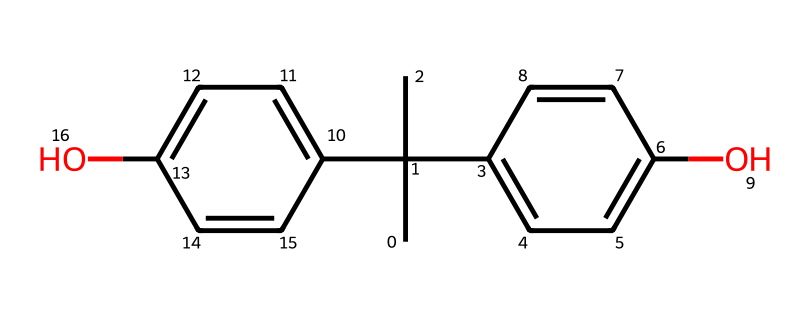What is the molecular formula of bisphenol A? To determine the molecular formula from the SMILES, we can parse it to identify the number and types of atoms present. In this case, the structure contains 15 carbon atoms, 16 hydrogen atoms, and 2 oxygen atoms. Thus, the molecular formula is C15H16O2.
Answer: C15H16O2 How many hydroxyl groups are present in bisphenol A? By examining the structure, we can identify the hydroxyl groups (-OH) which are represented by the oxygen atoms connected to carbon atoms. In this structure, there are 2 hydroxyl groups.
Answer: 2 What is the total number of rings in bisphenol A? The structure has two distinct aromatic rings (each having a cyclic structure), which can be identified by the connected carbon atoms and alternating double bonds. Therefore, the total number of rings is 2.
Answer: 2 What is the type of chemical structure for bisphenol A? Bisphenol A is categorized as a phenolic compound due to the presence of multiple phenol groups (hydroxyl groups on aromatic rings) in its structure. This defines its unique properties and applications in plastics.
Answer: phenolic Is bisphenol A a polar or nonpolar molecule? To analyze polarity, we assess the presence of functional groups and their arrangement. The hydroxyl groups contribute to polarity, and despite the hydrocarbon character, the overall structure is slightly polar due to these groups.
Answer: polar How many carbon rings does the aromatic component of bisphenol A have? Each aromatic component is a benzene ring, and in bisphenol A there are 2 benzene rings. Each aromatic ring contributes to the overall aromatic character of the compound.
Answer: 2 What is the bonding type primarily present in bisphenol A? The structure exhibits both sigma and pi bonds, primarily seen in the carbon-carbon connectivity and the aromatic rings where double bonds are present. This allows for resonance and stability.
Answer: covalent 